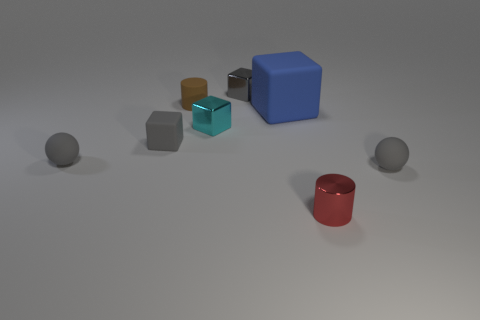Is there any other thing that has the same size as the blue object?
Ensure brevity in your answer.  No. What number of other things are the same color as the small matte block?
Ensure brevity in your answer.  3. There is a gray sphere right of the gray block behind the small cyan cube; what size is it?
Offer a very short reply. Small. Is the material of the small cylinder that is in front of the small matte block the same as the gray sphere on the right side of the large rubber cube?
Your answer should be very brief. No. There is a tiny rubber sphere that is left of the blue matte block; does it have the same color as the tiny matte cube?
Offer a terse response. Yes. There is a brown rubber object; what number of red shiny cylinders are behind it?
Make the answer very short. 0. Does the cyan thing have the same material as the sphere that is to the right of the brown rubber cylinder?
Your answer should be very brief. No. There is a gray thing that is made of the same material as the cyan thing; what is its size?
Offer a very short reply. Small. Are there more tiny shiny objects behind the small brown rubber cylinder than small spheres that are behind the big blue matte thing?
Your answer should be compact. Yes. Is there a tiny cyan object that has the same shape as the small red metal thing?
Give a very brief answer. No. 